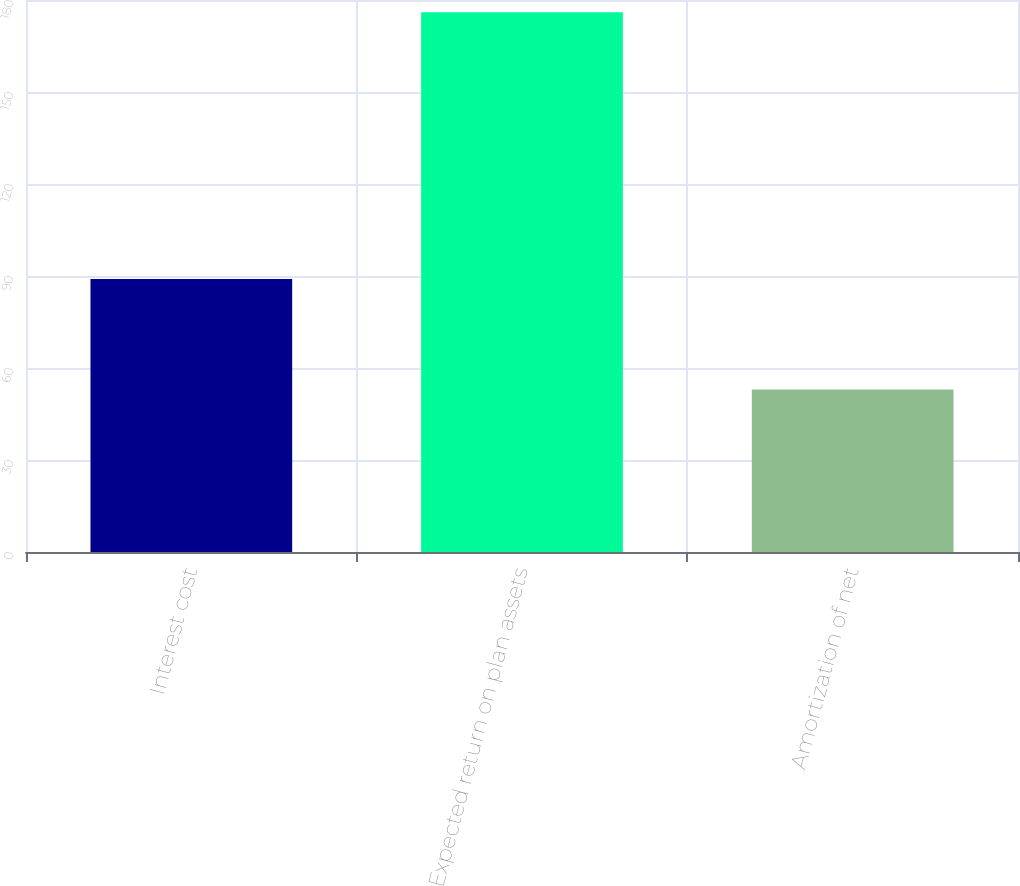<chart> <loc_0><loc_0><loc_500><loc_500><bar_chart><fcel>Interest cost<fcel>Expected return on plan assets<fcel>Amortization of net<nl><fcel>89<fcel>176<fcel>53<nl></chart> 